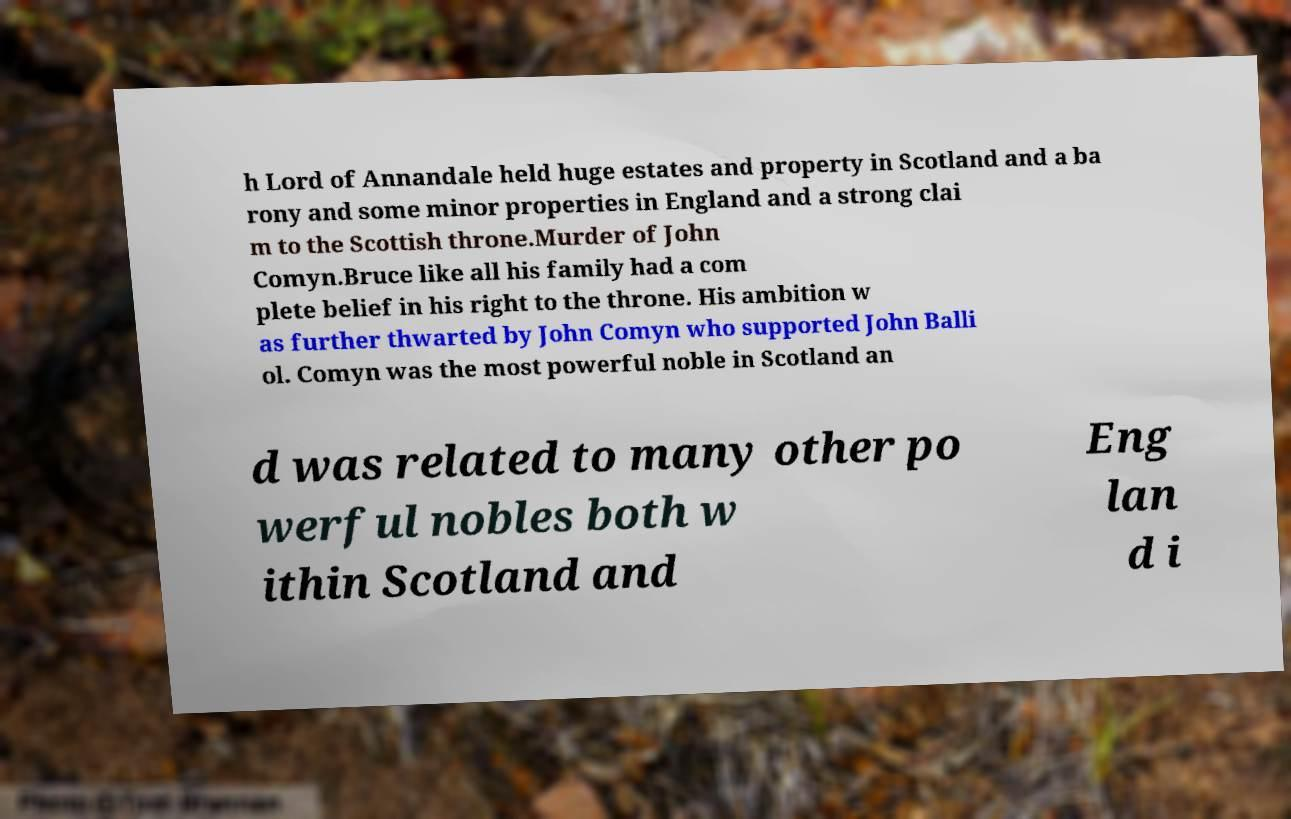For documentation purposes, I need the text within this image transcribed. Could you provide that? h Lord of Annandale held huge estates and property in Scotland and a ba rony and some minor properties in England and a strong clai m to the Scottish throne.Murder of John Comyn.Bruce like all his family had a com plete belief in his right to the throne. His ambition w as further thwarted by John Comyn who supported John Balli ol. Comyn was the most powerful noble in Scotland an d was related to many other po werful nobles both w ithin Scotland and Eng lan d i 